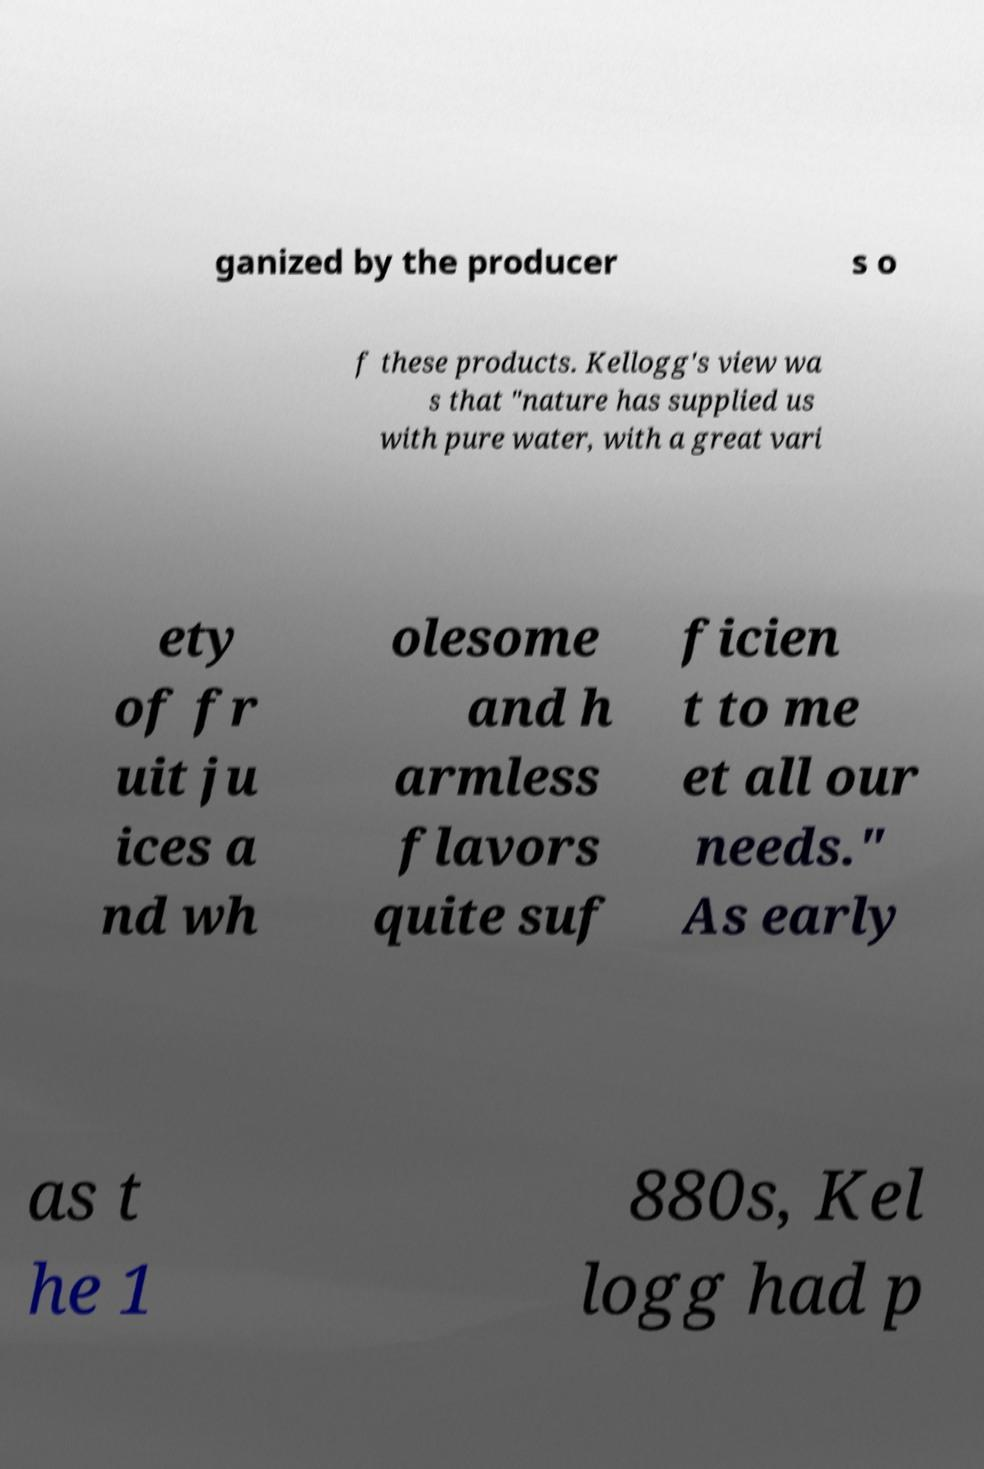Could you assist in decoding the text presented in this image and type it out clearly? ganized by the producer s o f these products. Kellogg's view wa s that "nature has supplied us with pure water, with a great vari ety of fr uit ju ices a nd wh olesome and h armless flavors quite suf ficien t to me et all our needs." As early as t he 1 880s, Kel logg had p 